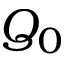<formula> <loc_0><loc_0><loc_500><loc_500>Q _ { 0 }</formula> 